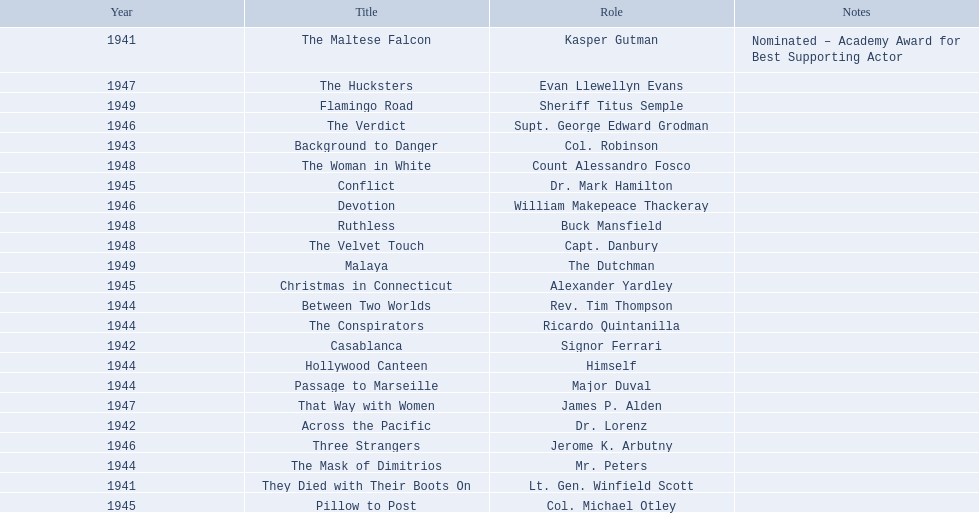What year was the movie that was nominated ? 1941. What was the title of the movie? The Maltese Falcon. 